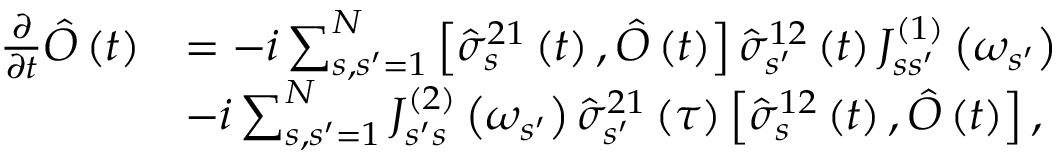Convert formula to latex. <formula><loc_0><loc_0><loc_500><loc_500>\begin{array} { r l } { \frac { \partial } { \partial t } \hat { O } \left ( t \right ) } & { = - i \sum _ { s , s ^ { \prime } = 1 } ^ { N } \left [ \hat { \sigma } _ { s } ^ { 2 1 } \left ( t \right ) , \hat { O } \left ( t \right ) \right ] \hat { \sigma } _ { s ^ { \prime } } ^ { 1 2 } \left ( t \right ) J _ { s s ^ { \prime } } ^ { \left ( 1 \right ) } \left ( \omega _ { s ^ { \prime } } \right ) } \\ & { - i \sum _ { s , s ^ { \prime } = 1 } ^ { N } J _ { s ^ { \prime } s } ^ { \left ( 2 \right ) } \left ( \omega _ { s ^ { \prime } } \right ) \hat { \sigma } _ { s ^ { \prime } } ^ { 2 1 } \left ( \tau \right ) \left [ \hat { \sigma } _ { s } ^ { 1 2 } \left ( t \right ) , \hat { O } \left ( t \right ) \right ] , } \end{array}</formula> 